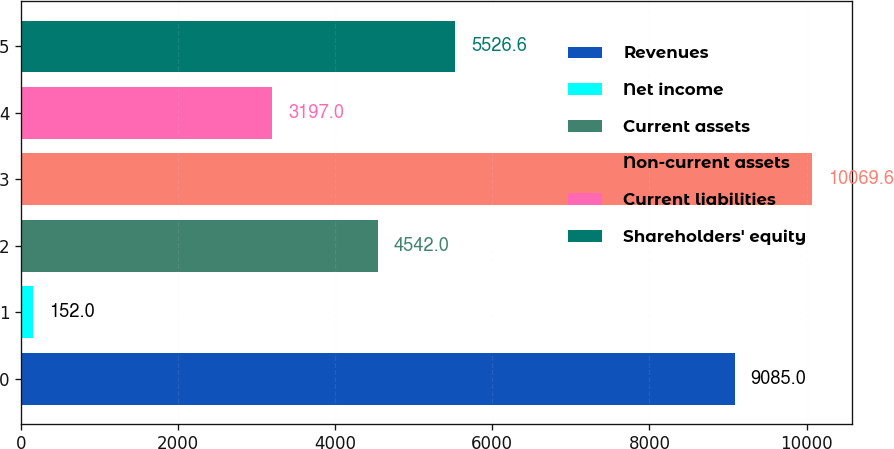Convert chart. <chart><loc_0><loc_0><loc_500><loc_500><bar_chart><fcel>Revenues<fcel>Net income<fcel>Current assets<fcel>Non-current assets<fcel>Current liabilities<fcel>Shareholders' equity<nl><fcel>9085<fcel>152<fcel>4542<fcel>10069.6<fcel>3197<fcel>5526.6<nl></chart> 